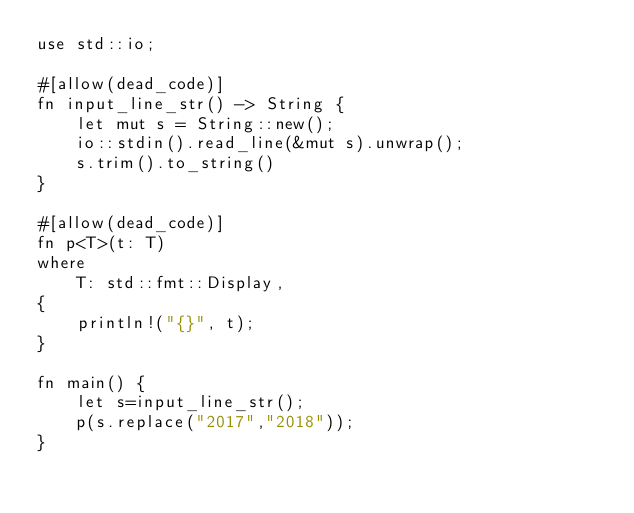<code> <loc_0><loc_0><loc_500><loc_500><_Rust_>use std::io;

#[allow(dead_code)]
fn input_line_str() -> String {
    let mut s = String::new();
    io::stdin().read_line(&mut s).unwrap();
    s.trim().to_string()
}

#[allow(dead_code)]
fn p<T>(t: T)
where
    T: std::fmt::Display,
{
    println!("{}", t);
}

fn main() {
    let s=input_line_str();
    p(s.replace("2017","2018"));
}</code> 